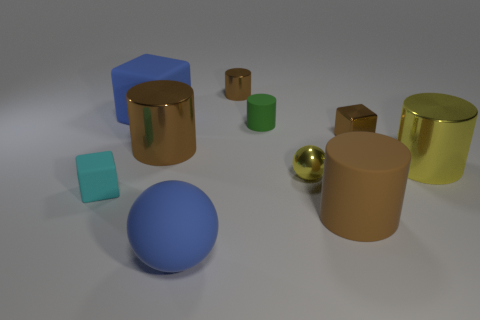There is a cube right of the small shiny cylinder; what color is it?
Provide a succinct answer. Brown. Are there any large blue matte balls in front of the brown cylinder to the right of the green matte cylinder?
Provide a succinct answer. Yes. Do the small cyan matte object and the brown metal object left of the matte sphere have the same shape?
Ensure brevity in your answer.  No. There is a matte object that is in front of the big yellow cylinder and behind the brown matte cylinder; what size is it?
Provide a short and direct response. Small. Are there any tiny yellow balls made of the same material as the blue cube?
Your answer should be very brief. No. The thing that is the same color as the rubber ball is what size?
Your answer should be very brief. Large. The block that is in front of the big yellow cylinder right of the big brown matte object is made of what material?
Provide a short and direct response. Rubber. How many big blocks are the same color as the big rubber sphere?
Give a very brief answer. 1. What size is the blue cube that is made of the same material as the cyan thing?
Provide a succinct answer. Large. There is a small brown thing behind the green matte object; what is its shape?
Provide a short and direct response. Cylinder. 